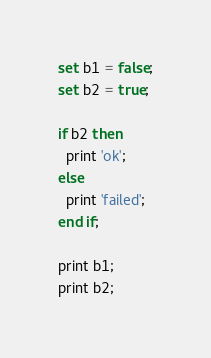Convert code to text. <code><loc_0><loc_0><loc_500><loc_500><_SQL_>set b1 = false;
set b2 = true;

if b2 then
  print 'ok';
else
  print 'failed';
end if;  

print b1;
print b2;</code> 